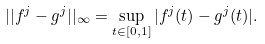Convert formula to latex. <formula><loc_0><loc_0><loc_500><loc_500>| | f ^ { j } - g ^ { j } | | _ { \infty } = \sup _ { t \in [ 0 , 1 ] } | f ^ { j } ( t ) - g ^ { j } ( t ) | .</formula> 